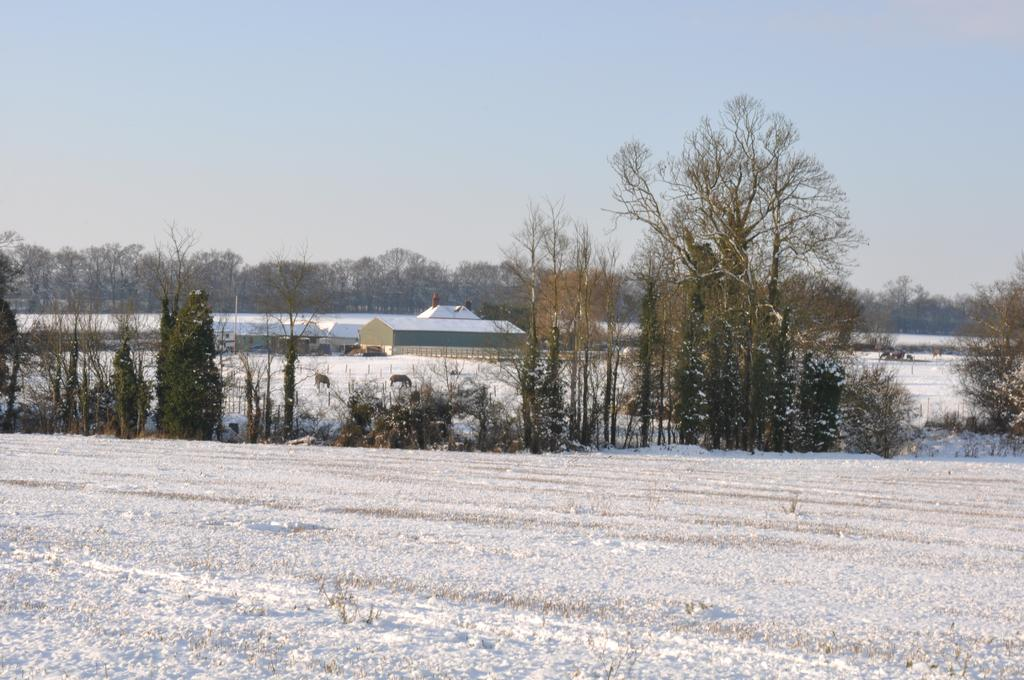What type of vegetation can be seen in the image? There are trees in the image. What is covering the ground in the image? There is snow on the ground in the image. What can be seen in the background of the image? There are trees and buildings in the background of the image. What part of the natural environment is visible in the image? The sky is visible in the background of the image. What action is the tree performing in the image? Trees do not perform actions; they are stationary objects. 